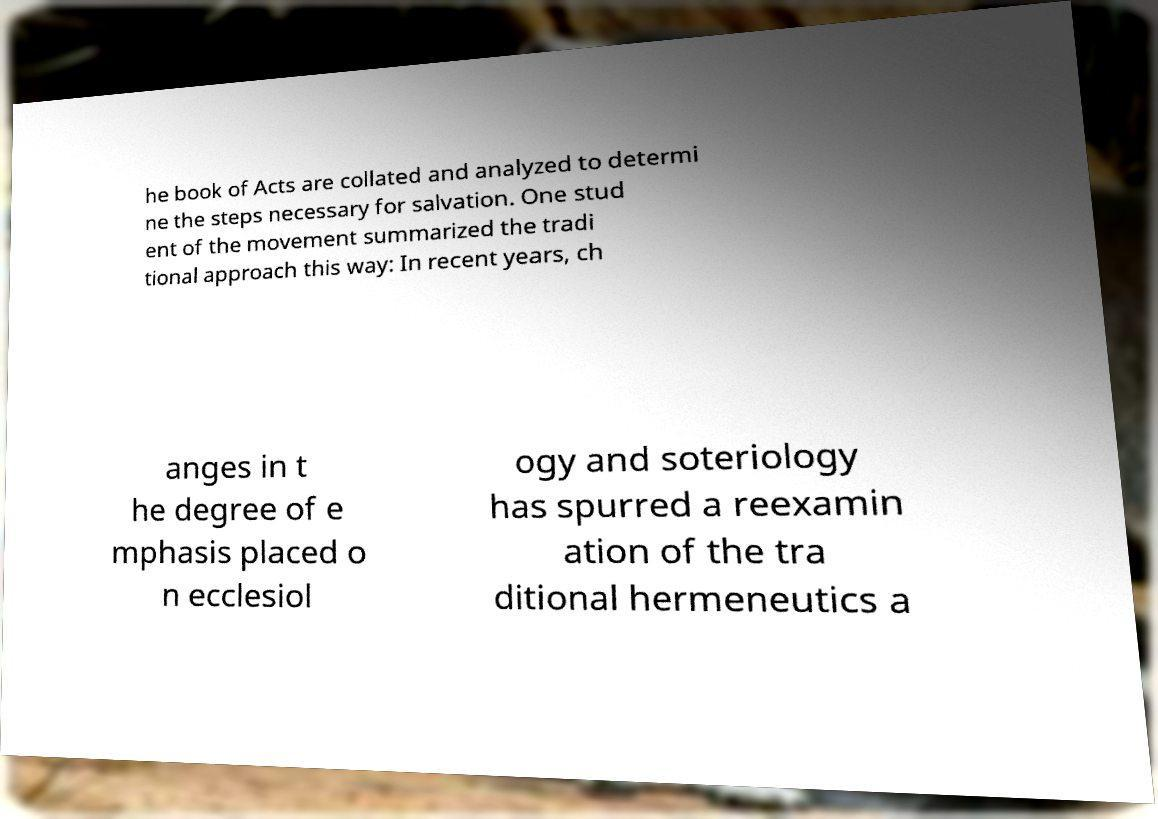There's text embedded in this image that I need extracted. Can you transcribe it verbatim? he book of Acts are collated and analyzed to determi ne the steps necessary for salvation. One stud ent of the movement summarized the tradi tional approach this way: In recent years, ch anges in t he degree of e mphasis placed o n ecclesiol ogy and soteriology has spurred a reexamin ation of the tra ditional hermeneutics a 